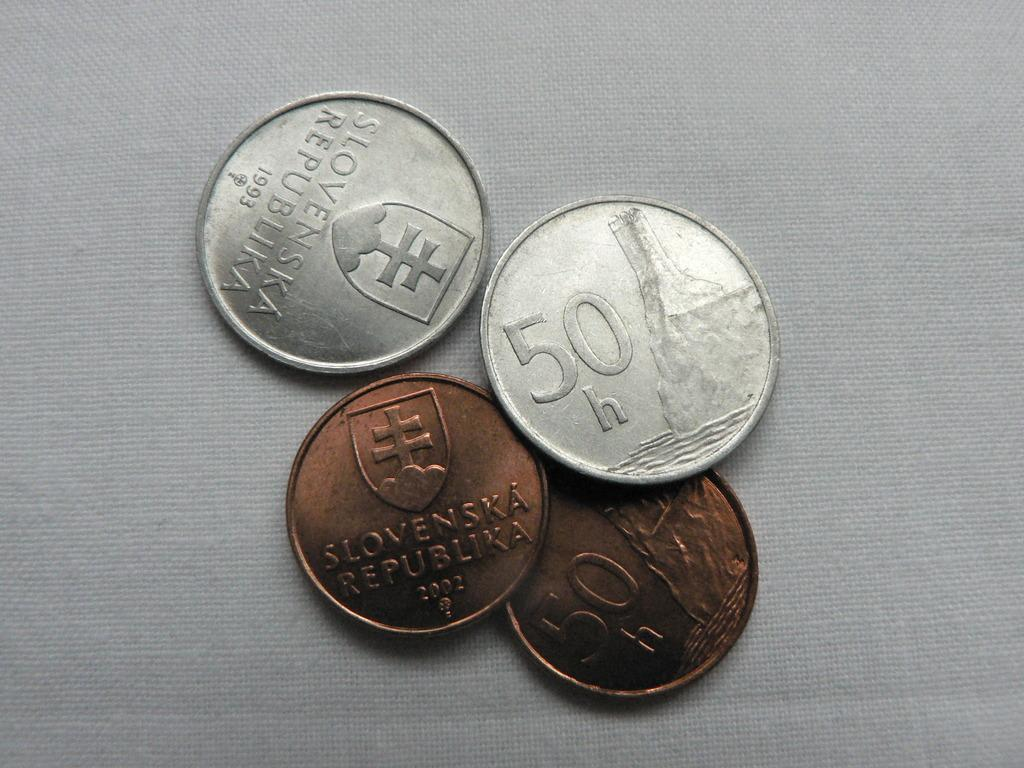<image>
Offer a succinct explanation of the picture presented. Four different coins and one with 50 h on it 